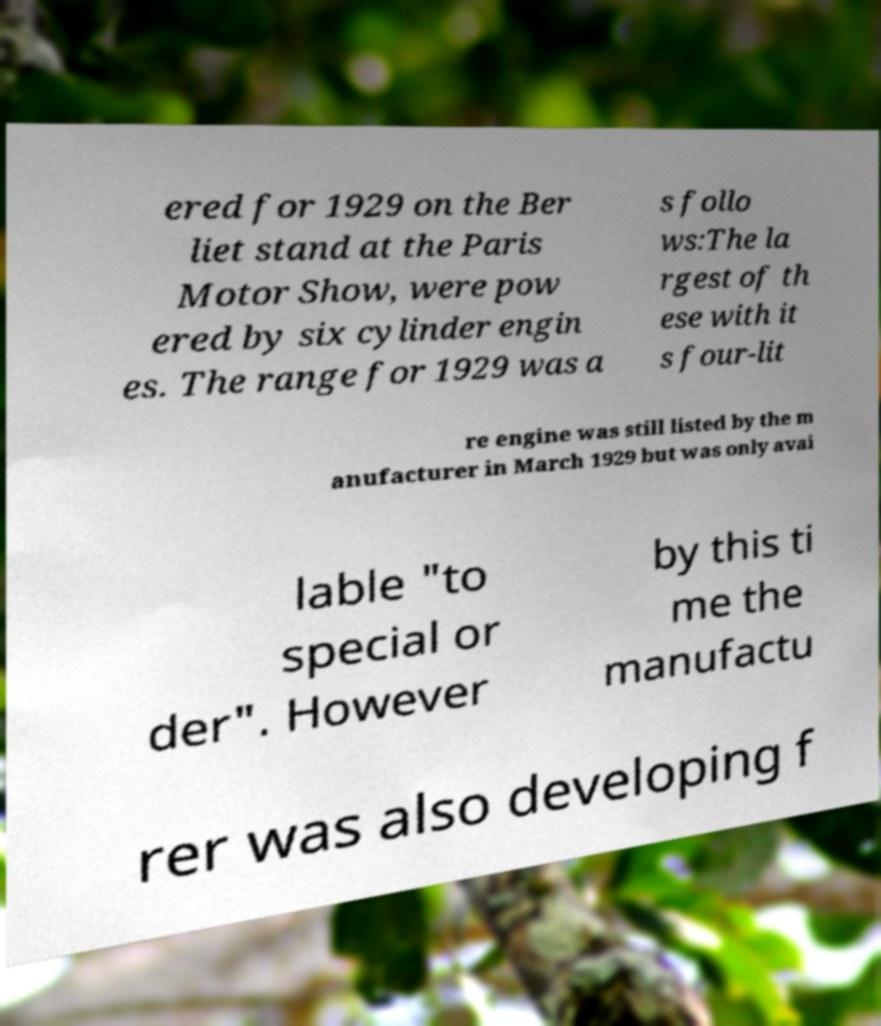For documentation purposes, I need the text within this image transcribed. Could you provide that? ered for 1929 on the Ber liet stand at the Paris Motor Show, were pow ered by six cylinder engin es. The range for 1929 was a s follo ws:The la rgest of th ese with it s four-lit re engine was still listed by the m anufacturer in March 1929 but was only avai lable "to special or der". However by this ti me the manufactu rer was also developing f 